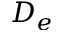<formula> <loc_0><loc_0><loc_500><loc_500>D _ { e }</formula> 